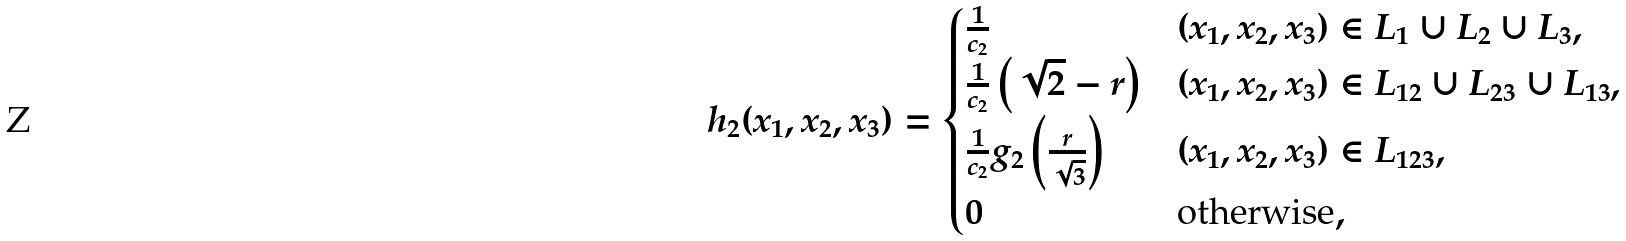Convert formula to latex. <formula><loc_0><loc_0><loc_500><loc_500>h _ { 2 } ( x _ { 1 } , x _ { 2 } , x _ { 3 } ) = \begin{cases} \frac { 1 } { c _ { 2 } } & ( x _ { 1 } , x _ { 2 } , x _ { 3 } ) \in L _ { 1 } \cup L _ { 2 } \cup L _ { 3 } , \\ \frac { 1 } { c _ { 2 } } \left ( \sqrt { 2 } - r \right ) & ( x _ { 1 } , x _ { 2 } , x _ { 3 } ) \in L _ { 1 2 } \cup L _ { 2 3 } \cup L _ { 1 3 } , \\ \frac { 1 } { c _ { 2 } } g _ { 2 } \left ( \frac { r } { \sqrt { 3 } } \right ) & ( x _ { 1 } , x _ { 2 } , x _ { 3 } ) \in L _ { 1 2 3 } , \\ 0 & \text {otherwise} , \end{cases}</formula> 